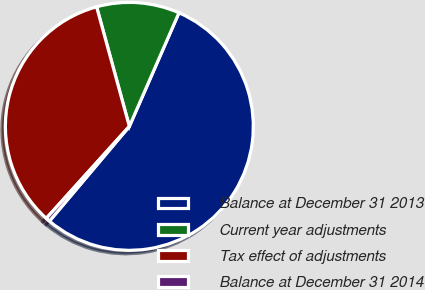<chart> <loc_0><loc_0><loc_500><loc_500><pie_chart><fcel>Balance at December 31 2013<fcel>Current year adjustments<fcel>Tax effect of adjustments<fcel>Balance at December 31 2014<nl><fcel>54.59%<fcel>10.81%<fcel>34.05%<fcel>0.54%<nl></chart> 